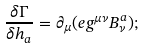Convert formula to latex. <formula><loc_0><loc_0><loc_500><loc_500>\frac { \delta \Gamma } { \delta h _ { a } } = \partial _ { \mu } ( e g ^ { \mu \nu } B _ { \nu } ^ { a } ) ;</formula> 